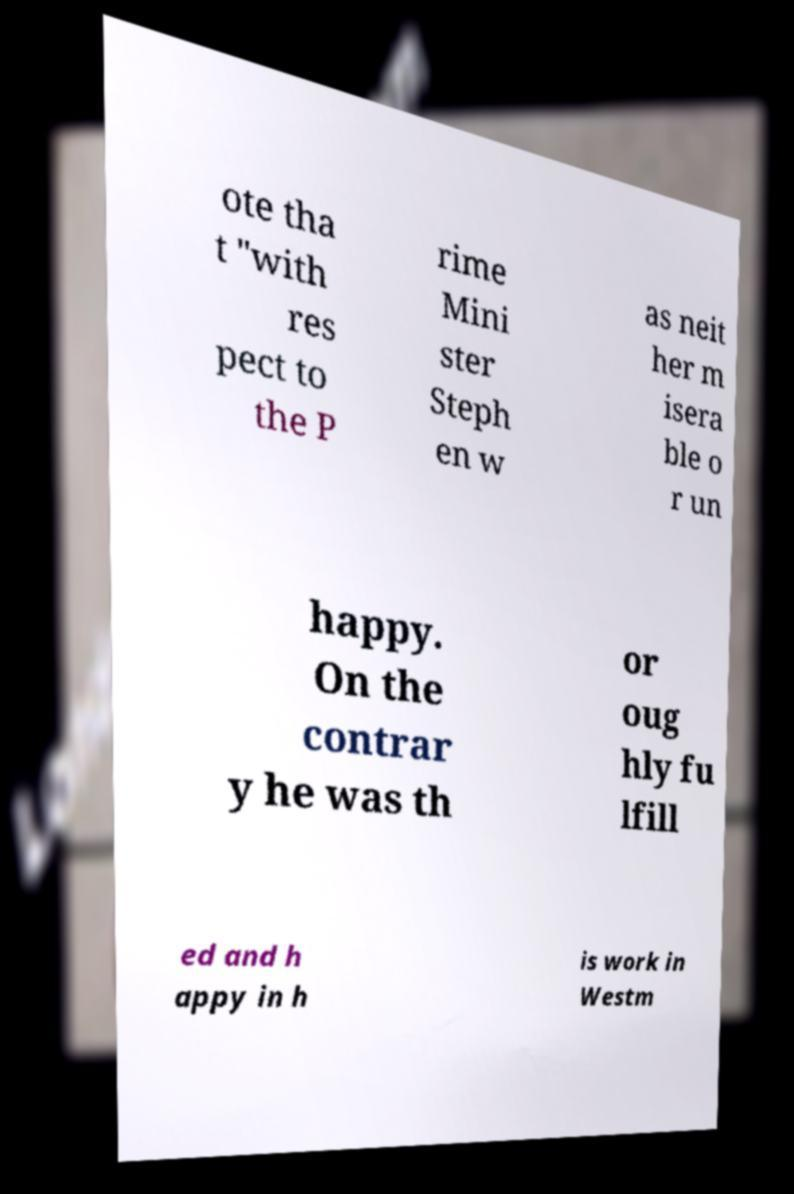Please identify and transcribe the text found in this image. ote tha t "with res pect to the P rime Mini ster Steph en w as neit her m isera ble o r un happy. On the contrar y he was th or oug hly fu lfill ed and h appy in h is work in Westm 